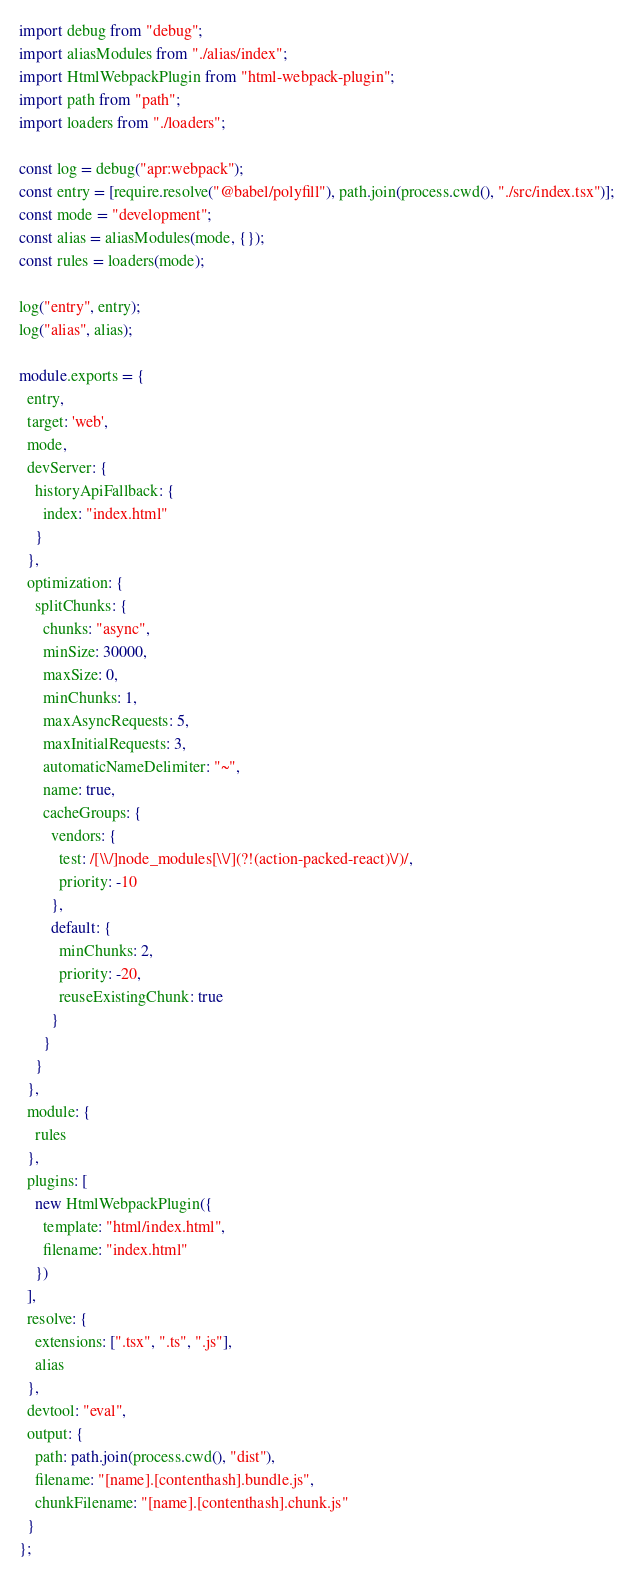Convert code to text. <code><loc_0><loc_0><loc_500><loc_500><_TypeScript_>import debug from "debug";
import aliasModules from "./alias/index";
import HtmlWebpackPlugin from "html-webpack-plugin";
import path from "path";
import loaders from "./loaders";

const log = debug("apr:webpack");
const entry = [require.resolve("@babel/polyfill"), path.join(process.cwd(), "./src/index.tsx")];
const mode = "development";
const alias = aliasModules(mode, {});
const rules = loaders(mode);

log("entry", entry);
log("alias", alias);

module.exports = {
  entry,
  target: 'web',
  mode,
  devServer: {
    historyApiFallback: {
      index: "index.html"
    }
  },
  optimization: {
    splitChunks: {
      chunks: "async",
      minSize: 30000,
      maxSize: 0,
      minChunks: 1,
      maxAsyncRequests: 5,
      maxInitialRequests: 3,
      automaticNameDelimiter: "~",
      name: true,
      cacheGroups: {
        vendors: {
          test: /[\\/]node_modules[\\/](?!(action-packed-react)\/)/,
          priority: -10
        },
        default: {
          minChunks: 2,
          priority: -20,
          reuseExistingChunk: true
        }
      }
    }
  },
  module: {
    rules
  },
  plugins: [
    new HtmlWebpackPlugin({
      template: "html/index.html",
      filename: "index.html"
    })
  ],
  resolve: {
    extensions: [".tsx", ".ts", ".js"],
    alias
  },
  devtool: "eval",
  output: {
    path: path.join(process.cwd(), "dist"),
    filename: "[name].[contenthash].bundle.js",
    chunkFilename: "[name].[contenthash].chunk.js"
  }
};
</code> 